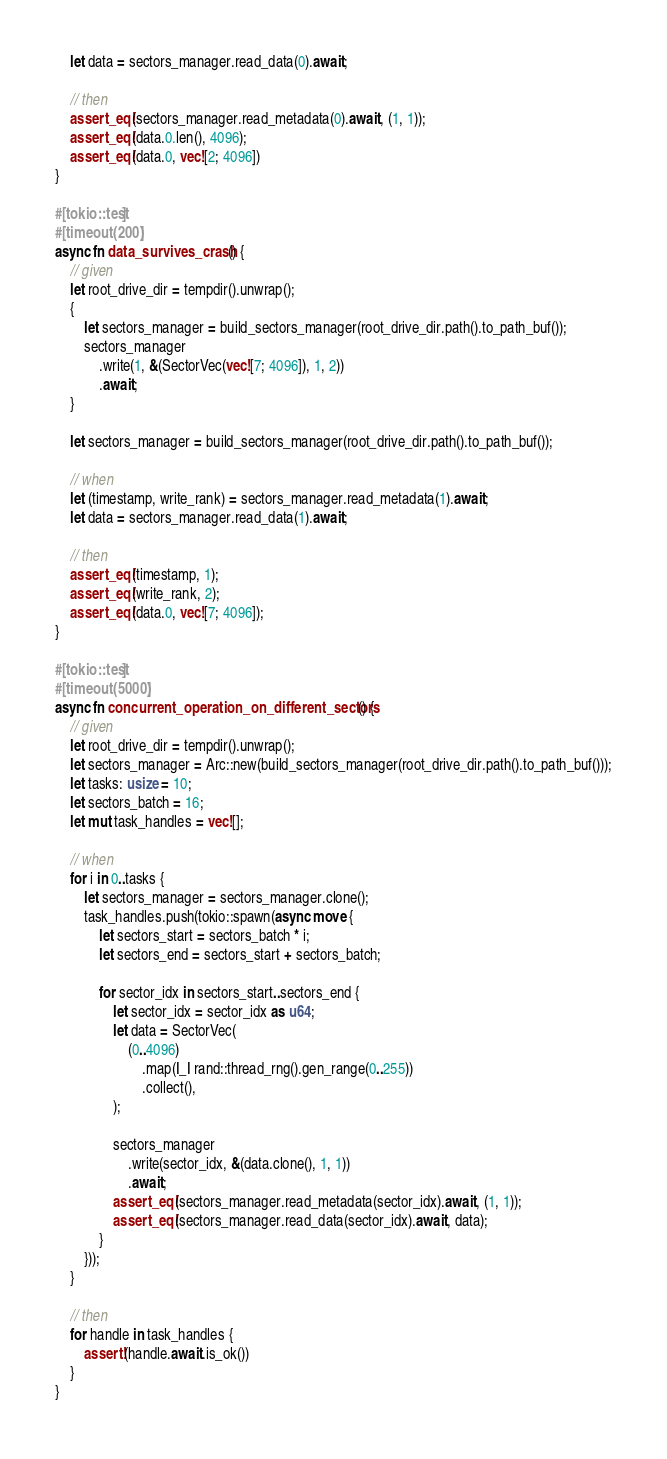Convert code to text. <code><loc_0><loc_0><loc_500><loc_500><_Rust_>    let data = sectors_manager.read_data(0).await;

    // then
    assert_eq!(sectors_manager.read_metadata(0).await, (1, 1));
    assert_eq!(data.0.len(), 4096);
    assert_eq!(data.0, vec![2; 4096])
}

#[tokio::test]
#[timeout(200)]
async fn data_survives_crash() {
    // given
    let root_drive_dir = tempdir().unwrap();
    {
        let sectors_manager = build_sectors_manager(root_drive_dir.path().to_path_buf());
        sectors_manager
            .write(1, &(SectorVec(vec![7; 4096]), 1, 2))
            .await;
    }

    let sectors_manager = build_sectors_manager(root_drive_dir.path().to_path_buf());

    // when
    let (timestamp, write_rank) = sectors_manager.read_metadata(1).await;
    let data = sectors_manager.read_data(1).await;

    // then
    assert_eq!(timestamp, 1);
    assert_eq!(write_rank, 2);
    assert_eq!(data.0, vec![7; 4096]);
}

#[tokio::test]
#[timeout(5000)]
async fn concurrent_operation_on_different_sectors() {
    // given
    let root_drive_dir = tempdir().unwrap();
    let sectors_manager = Arc::new(build_sectors_manager(root_drive_dir.path().to_path_buf()));
    let tasks: usize = 10;
    let sectors_batch = 16;
    let mut task_handles = vec![];

    // when
    for i in 0..tasks {
        let sectors_manager = sectors_manager.clone();
        task_handles.push(tokio::spawn(async move {
            let sectors_start = sectors_batch * i;
            let sectors_end = sectors_start + sectors_batch;

            for sector_idx in sectors_start..sectors_end {
                let sector_idx = sector_idx as u64;
                let data = SectorVec(
                    (0..4096)
                        .map(|_| rand::thread_rng().gen_range(0..255))
                        .collect(),
                );

                sectors_manager
                    .write(sector_idx, &(data.clone(), 1, 1))
                    .await;
                assert_eq!(sectors_manager.read_metadata(sector_idx).await, (1, 1));
                assert_eq!(sectors_manager.read_data(sector_idx).await, data);
            }
        }));
    }

    // then
    for handle in task_handles {
        assert!(handle.await.is_ok())
    }
}
</code> 